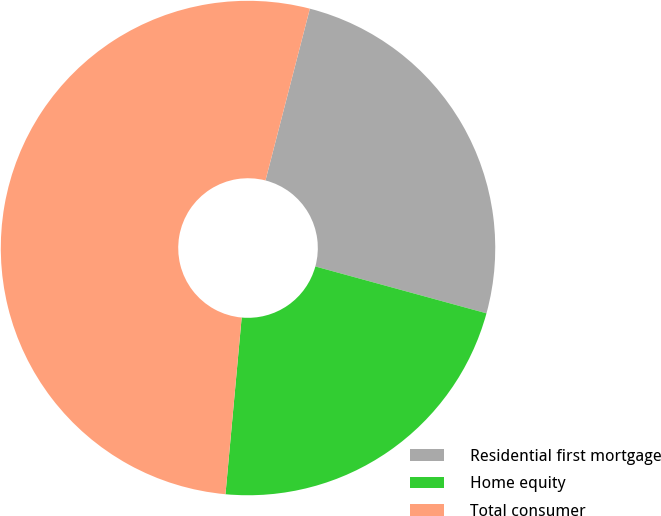<chart> <loc_0><loc_0><loc_500><loc_500><pie_chart><fcel>Residential first mortgage<fcel>Home equity<fcel>Total consumer<nl><fcel>25.23%<fcel>22.2%<fcel>52.57%<nl></chart> 